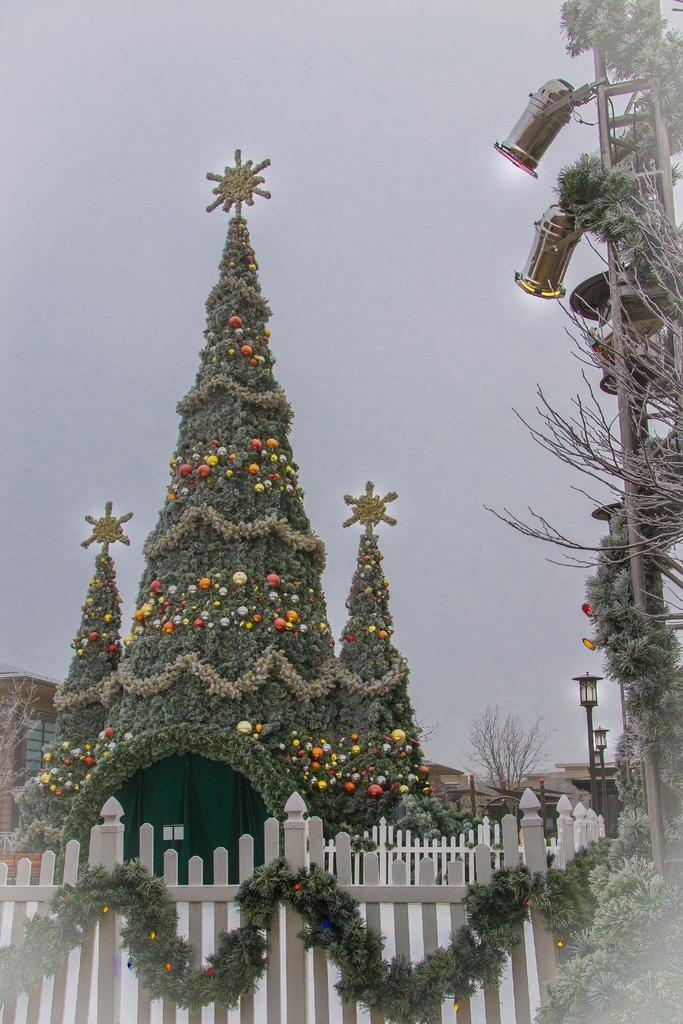Please provide a concise description of this image. In the picture I can see fence, lights, fence, a house decorated with something. In the background I can see the sky. 